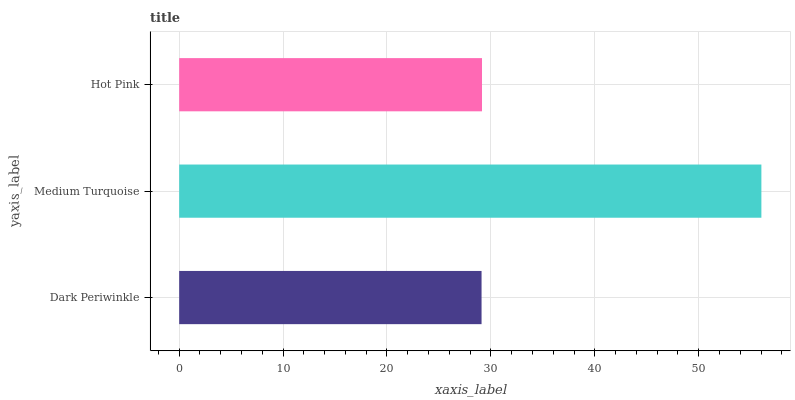Is Dark Periwinkle the minimum?
Answer yes or no. Yes. Is Medium Turquoise the maximum?
Answer yes or no. Yes. Is Hot Pink the minimum?
Answer yes or no. No. Is Hot Pink the maximum?
Answer yes or no. No. Is Medium Turquoise greater than Hot Pink?
Answer yes or no. Yes. Is Hot Pink less than Medium Turquoise?
Answer yes or no. Yes. Is Hot Pink greater than Medium Turquoise?
Answer yes or no. No. Is Medium Turquoise less than Hot Pink?
Answer yes or no. No. Is Hot Pink the high median?
Answer yes or no. Yes. Is Hot Pink the low median?
Answer yes or no. Yes. Is Dark Periwinkle the high median?
Answer yes or no. No. Is Dark Periwinkle the low median?
Answer yes or no. No. 